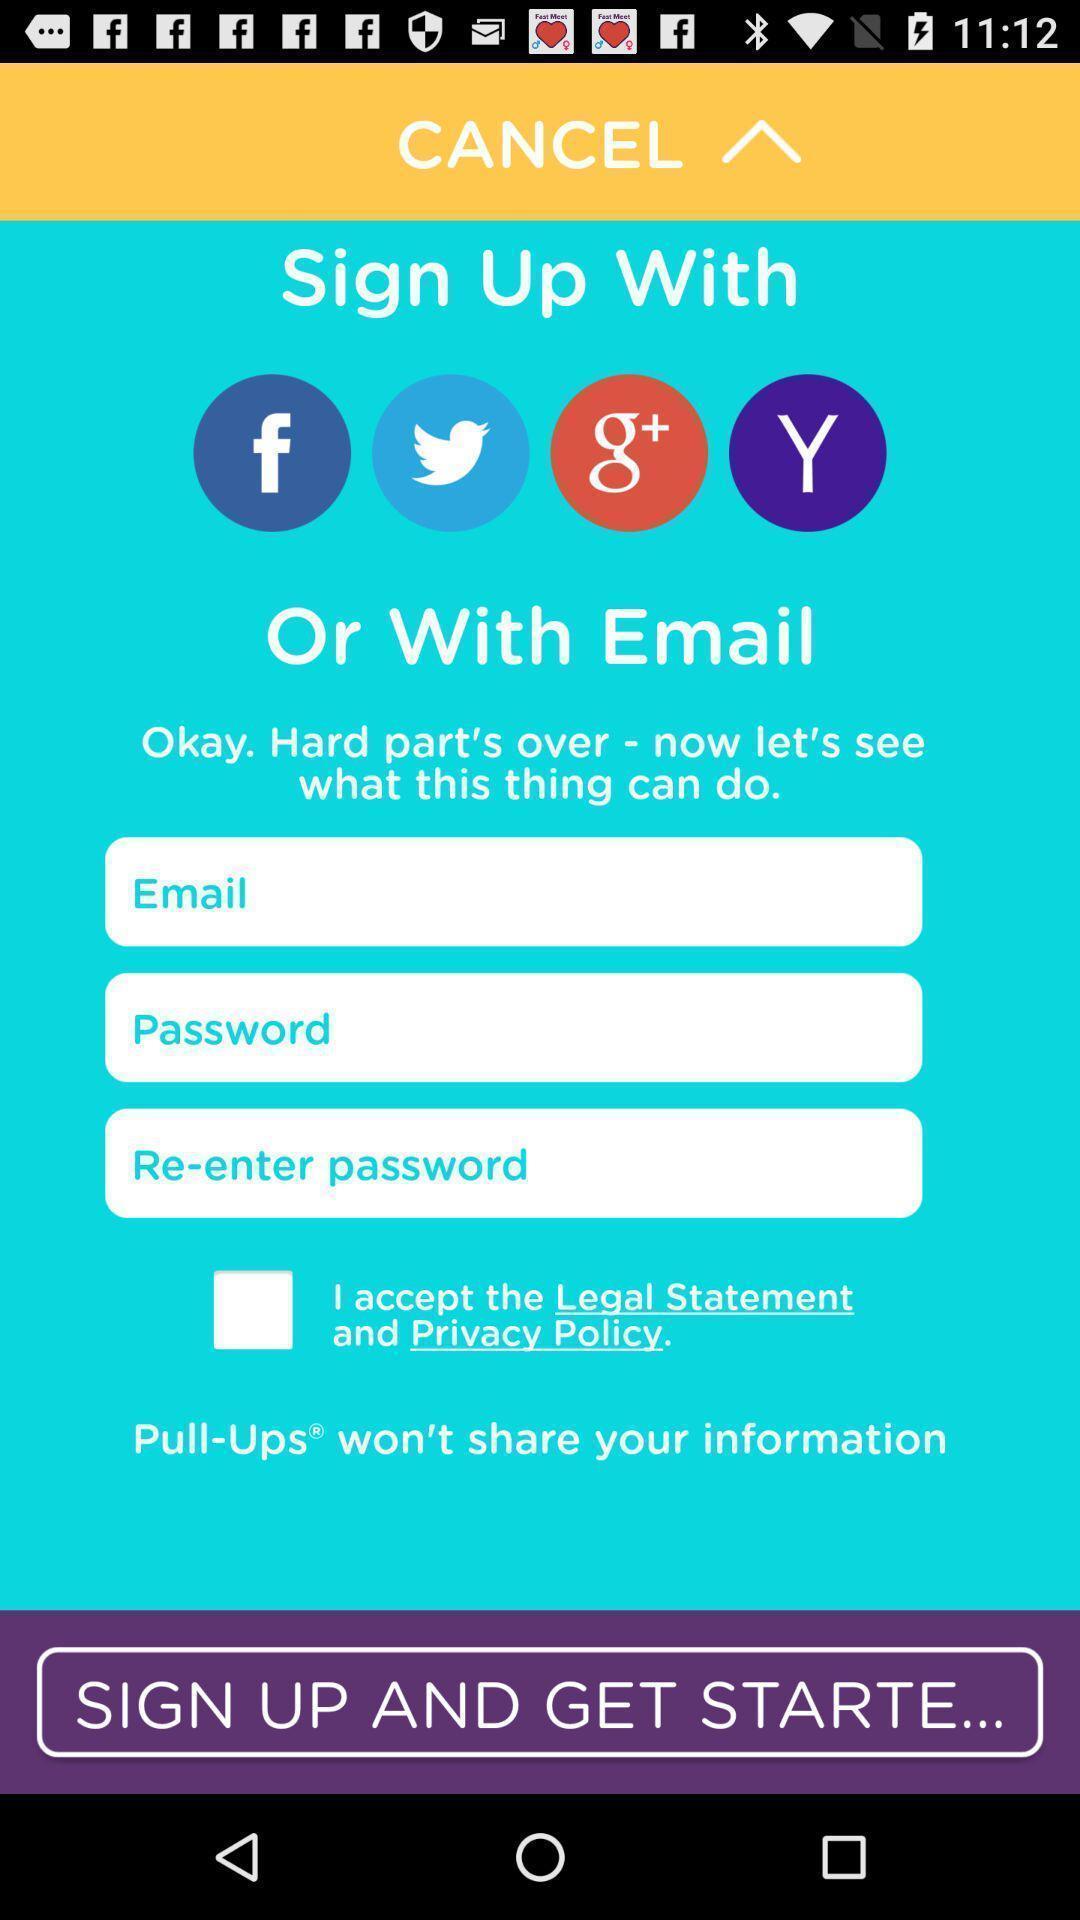Please provide a description for this image. Sign up page. 